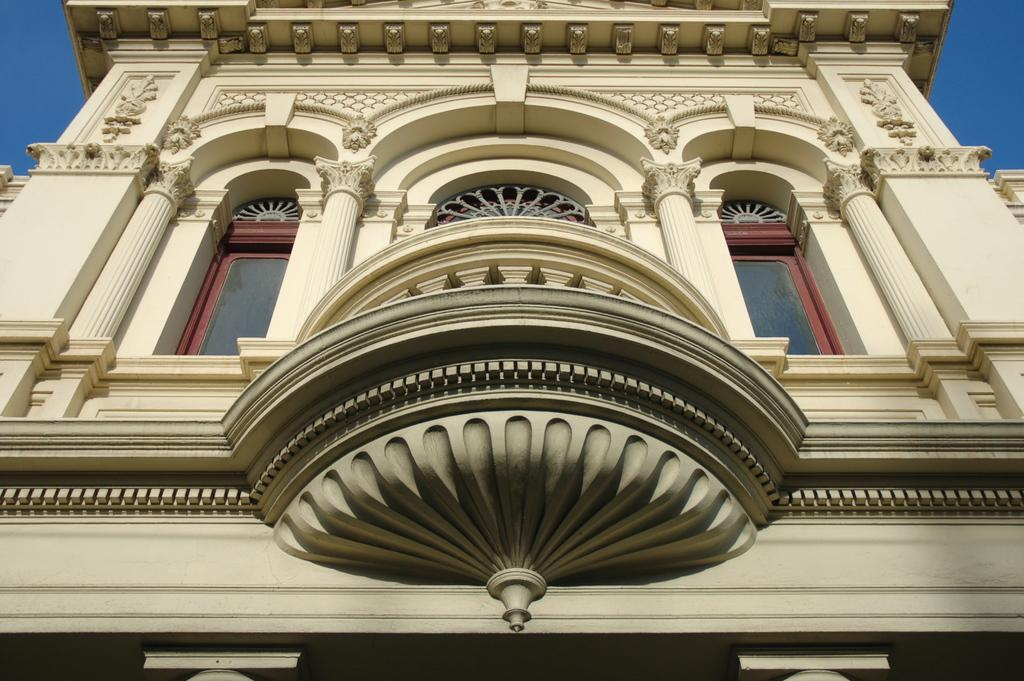What type of structure is in the image? There is a building in the image. What architectural features can be seen on the building? The building has pillars and glass windows. What material is used for the walls of the building? The building has walls made of a material that allows for carvings. What is visible in the top corners of the image? The sky is visible in the top corners of the image (right and left sides). What day of the week is depicted in the carving on the walls? There is no day of the week depicted in the carving on the walls, as the image does not show any text or symbols related to a specific day. 